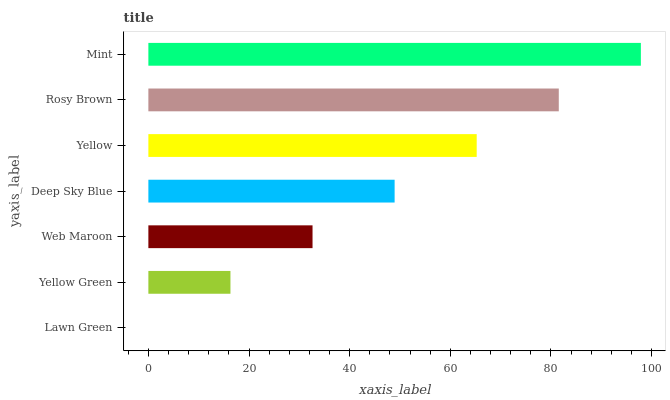Is Lawn Green the minimum?
Answer yes or no. Yes. Is Mint the maximum?
Answer yes or no. Yes. Is Yellow Green the minimum?
Answer yes or no. No. Is Yellow Green the maximum?
Answer yes or no. No. Is Yellow Green greater than Lawn Green?
Answer yes or no. Yes. Is Lawn Green less than Yellow Green?
Answer yes or no. Yes. Is Lawn Green greater than Yellow Green?
Answer yes or no. No. Is Yellow Green less than Lawn Green?
Answer yes or no. No. Is Deep Sky Blue the high median?
Answer yes or no. Yes. Is Deep Sky Blue the low median?
Answer yes or no. Yes. Is Web Maroon the high median?
Answer yes or no. No. Is Lawn Green the low median?
Answer yes or no. No. 